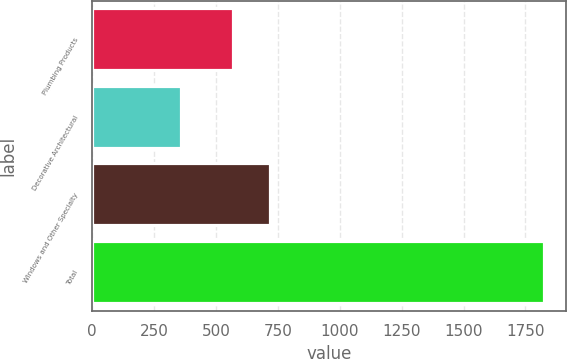Convert chart. <chart><loc_0><loc_0><loc_500><loc_500><bar_chart><fcel>Plumbing Products<fcel>Decorative Architectural<fcel>Windows and Other Specialty<fcel>Total<nl><fcel>568<fcel>358<fcel>717<fcel>1824<nl></chart> 